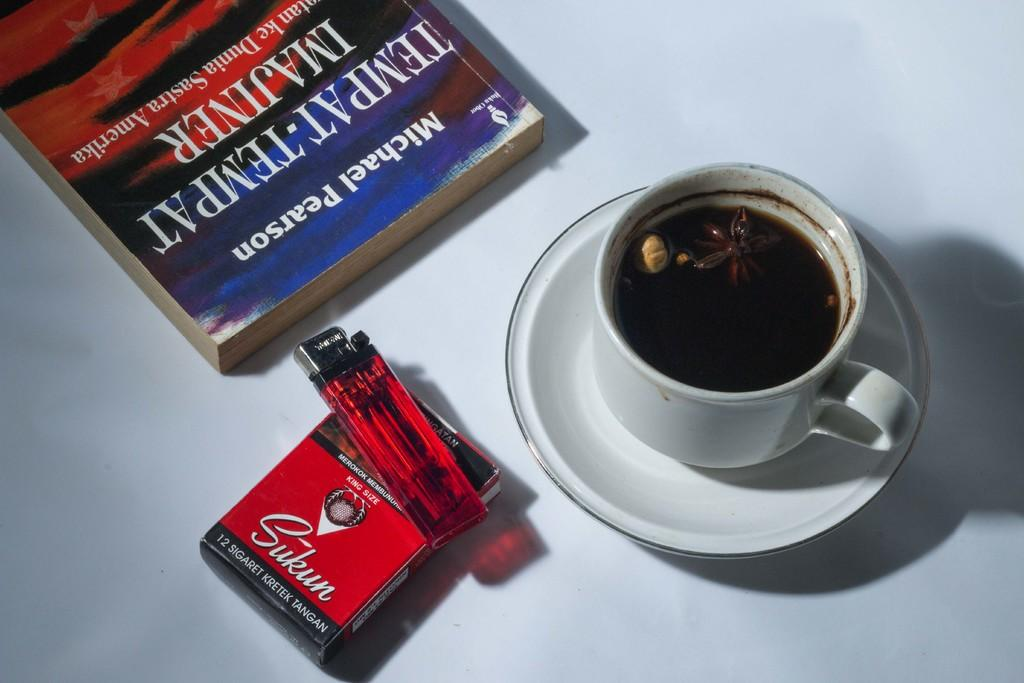What beverage is in the cup that is visible in the image? There is a cup of tea in the image. What other items can be seen in the image besides the cup of tea? There is a pack of cigarettes, a lighter, and a book visible in the image. Where are all these objects located in the image? All these objects are placed on a table in the image. What type of sack is being used for the treatment of the stocking in the image? There is no sack or stocking present in the image. 